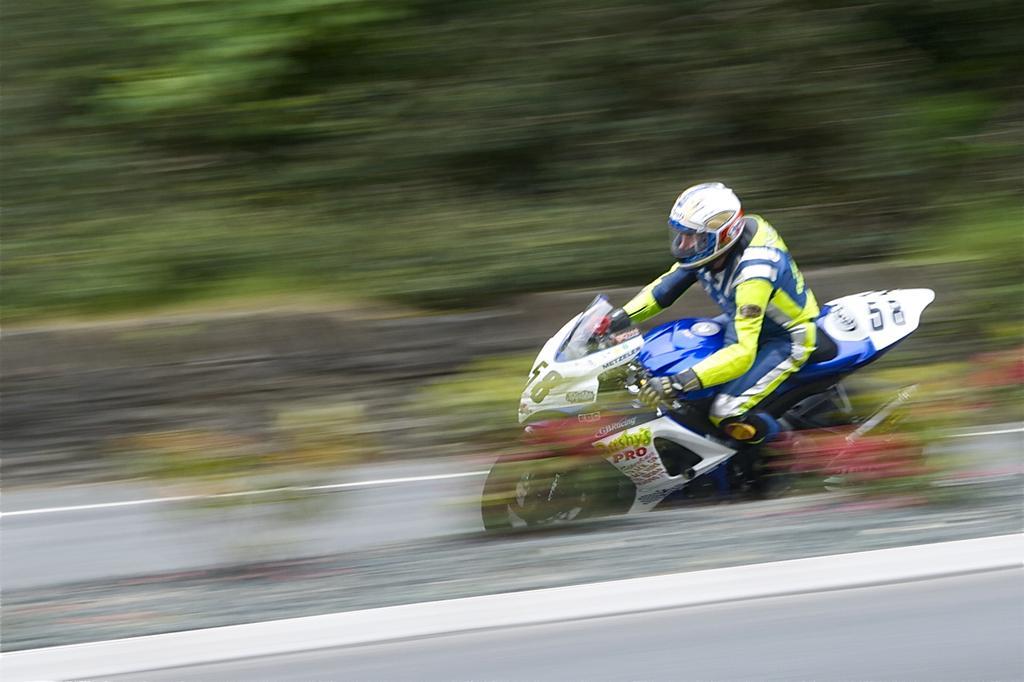Can you describe this image briefly? In this image I can see a person wearing green and blue colored dress and white color helmet is riding a motor bike which is white, blue and black in color. I can see the blurry background which is green in color. 